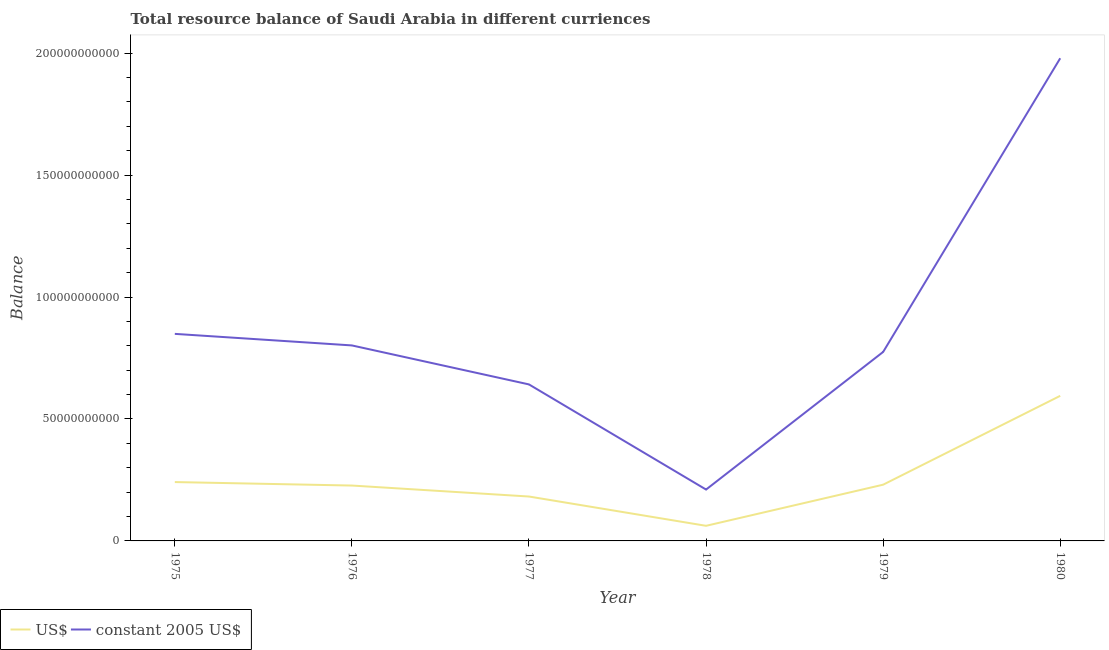Does the line corresponding to resource balance in us$ intersect with the line corresponding to resource balance in constant us$?
Make the answer very short. No. Is the number of lines equal to the number of legend labels?
Offer a terse response. Yes. What is the resource balance in us$ in 1977?
Provide a succinct answer. 1.82e+1. Across all years, what is the maximum resource balance in constant us$?
Offer a very short reply. 1.98e+11. Across all years, what is the minimum resource balance in constant us$?
Give a very brief answer. 2.11e+1. In which year was the resource balance in us$ minimum?
Your response must be concise. 1978. What is the total resource balance in us$ in the graph?
Your response must be concise. 1.54e+11. What is the difference between the resource balance in us$ in 1975 and that in 1979?
Provide a short and direct response. 1.08e+09. What is the difference between the resource balance in us$ in 1975 and the resource balance in constant us$ in 1976?
Your answer should be compact. -5.60e+1. What is the average resource balance in constant us$ per year?
Your answer should be compact. 8.76e+1. In the year 1979, what is the difference between the resource balance in constant us$ and resource balance in us$?
Your response must be concise. 5.44e+1. What is the ratio of the resource balance in constant us$ in 1978 to that in 1979?
Your answer should be very brief. 0.27. What is the difference between the highest and the second highest resource balance in us$?
Offer a terse response. 3.54e+1. What is the difference between the highest and the lowest resource balance in constant us$?
Your answer should be very brief. 1.77e+11. In how many years, is the resource balance in us$ greater than the average resource balance in us$ taken over all years?
Ensure brevity in your answer.  1. Is the sum of the resource balance in us$ in 1979 and 1980 greater than the maximum resource balance in constant us$ across all years?
Provide a short and direct response. No. Is the resource balance in constant us$ strictly greater than the resource balance in us$ over the years?
Offer a terse response. Yes. How many lines are there?
Your answer should be compact. 2. Are the values on the major ticks of Y-axis written in scientific E-notation?
Provide a succinct answer. No. How many legend labels are there?
Your answer should be very brief. 2. How are the legend labels stacked?
Your answer should be very brief. Horizontal. What is the title of the graph?
Provide a short and direct response. Total resource balance of Saudi Arabia in different curriences. What is the label or title of the X-axis?
Give a very brief answer. Year. What is the label or title of the Y-axis?
Offer a very short reply. Balance. What is the Balance of US$ in 1975?
Provide a short and direct response. 2.41e+1. What is the Balance of constant 2005 US$ in 1975?
Give a very brief answer. 8.49e+1. What is the Balance of US$ in 1976?
Your answer should be very brief. 2.27e+1. What is the Balance in constant 2005 US$ in 1976?
Give a very brief answer. 8.02e+1. What is the Balance in US$ in 1977?
Offer a terse response. 1.82e+1. What is the Balance in constant 2005 US$ in 1977?
Your answer should be compact. 6.42e+1. What is the Balance in US$ in 1978?
Ensure brevity in your answer.  6.20e+09. What is the Balance of constant 2005 US$ in 1978?
Make the answer very short. 2.11e+1. What is the Balance in US$ in 1979?
Offer a terse response. 2.31e+1. What is the Balance of constant 2005 US$ in 1979?
Give a very brief answer. 7.75e+1. What is the Balance in US$ in 1980?
Keep it short and to the point. 5.95e+1. What is the Balance of constant 2005 US$ in 1980?
Your answer should be compact. 1.98e+11. Across all years, what is the maximum Balance in US$?
Your answer should be very brief. 5.95e+1. Across all years, what is the maximum Balance of constant 2005 US$?
Offer a terse response. 1.98e+11. Across all years, what is the minimum Balance of US$?
Offer a terse response. 6.20e+09. Across all years, what is the minimum Balance in constant 2005 US$?
Your answer should be very brief. 2.11e+1. What is the total Balance of US$ in the graph?
Your answer should be very brief. 1.54e+11. What is the total Balance in constant 2005 US$ in the graph?
Provide a short and direct response. 5.26e+11. What is the difference between the Balance of US$ in 1975 and that in 1976?
Provide a short and direct response. 1.43e+09. What is the difference between the Balance of constant 2005 US$ in 1975 and that in 1976?
Keep it short and to the point. 4.74e+09. What is the difference between the Balance in US$ in 1975 and that in 1977?
Offer a very short reply. 5.93e+09. What is the difference between the Balance of constant 2005 US$ in 1975 and that in 1977?
Offer a terse response. 2.07e+1. What is the difference between the Balance of US$ in 1975 and that in 1978?
Ensure brevity in your answer.  1.79e+1. What is the difference between the Balance in constant 2005 US$ in 1975 and that in 1978?
Your response must be concise. 6.38e+1. What is the difference between the Balance in US$ in 1975 and that in 1979?
Offer a terse response. 1.08e+09. What is the difference between the Balance of constant 2005 US$ in 1975 and that in 1979?
Offer a terse response. 7.41e+09. What is the difference between the Balance in US$ in 1975 and that in 1980?
Make the answer very short. -3.54e+1. What is the difference between the Balance of constant 2005 US$ in 1975 and that in 1980?
Your response must be concise. -1.13e+11. What is the difference between the Balance in US$ in 1976 and that in 1977?
Keep it short and to the point. 4.50e+09. What is the difference between the Balance in constant 2005 US$ in 1976 and that in 1977?
Your response must be concise. 1.60e+1. What is the difference between the Balance in US$ in 1976 and that in 1978?
Your answer should be compact. 1.65e+1. What is the difference between the Balance in constant 2005 US$ in 1976 and that in 1978?
Keep it short and to the point. 5.91e+1. What is the difference between the Balance of US$ in 1976 and that in 1979?
Ensure brevity in your answer.  -3.49e+08. What is the difference between the Balance of constant 2005 US$ in 1976 and that in 1979?
Provide a succinct answer. 2.67e+09. What is the difference between the Balance of US$ in 1976 and that in 1980?
Your response must be concise. -3.68e+1. What is the difference between the Balance in constant 2005 US$ in 1976 and that in 1980?
Make the answer very short. -1.18e+11. What is the difference between the Balance of US$ in 1977 and that in 1978?
Make the answer very short. 1.20e+1. What is the difference between the Balance of constant 2005 US$ in 1977 and that in 1978?
Your response must be concise. 4.31e+1. What is the difference between the Balance of US$ in 1977 and that in 1979?
Keep it short and to the point. -4.85e+09. What is the difference between the Balance in constant 2005 US$ in 1977 and that in 1979?
Your answer should be compact. -1.33e+1. What is the difference between the Balance in US$ in 1977 and that in 1980?
Ensure brevity in your answer.  -4.13e+1. What is the difference between the Balance in constant 2005 US$ in 1977 and that in 1980?
Your answer should be compact. -1.34e+11. What is the difference between the Balance of US$ in 1978 and that in 1979?
Offer a terse response. -1.69e+1. What is the difference between the Balance of constant 2005 US$ in 1978 and that in 1979?
Your answer should be very brief. -5.64e+1. What is the difference between the Balance of US$ in 1978 and that in 1980?
Ensure brevity in your answer.  -5.33e+1. What is the difference between the Balance of constant 2005 US$ in 1978 and that in 1980?
Give a very brief answer. -1.77e+11. What is the difference between the Balance in US$ in 1979 and that in 1980?
Offer a terse response. -3.64e+1. What is the difference between the Balance of constant 2005 US$ in 1979 and that in 1980?
Ensure brevity in your answer.  -1.20e+11. What is the difference between the Balance in US$ in 1975 and the Balance in constant 2005 US$ in 1976?
Provide a short and direct response. -5.60e+1. What is the difference between the Balance in US$ in 1975 and the Balance in constant 2005 US$ in 1977?
Your answer should be compact. -4.00e+1. What is the difference between the Balance of US$ in 1975 and the Balance of constant 2005 US$ in 1978?
Offer a terse response. 3.07e+09. What is the difference between the Balance in US$ in 1975 and the Balance in constant 2005 US$ in 1979?
Ensure brevity in your answer.  -5.34e+1. What is the difference between the Balance in US$ in 1975 and the Balance in constant 2005 US$ in 1980?
Ensure brevity in your answer.  -1.74e+11. What is the difference between the Balance of US$ in 1976 and the Balance of constant 2005 US$ in 1977?
Provide a succinct answer. -4.15e+1. What is the difference between the Balance in US$ in 1976 and the Balance in constant 2005 US$ in 1978?
Your response must be concise. 1.64e+09. What is the difference between the Balance of US$ in 1976 and the Balance of constant 2005 US$ in 1979?
Offer a terse response. -5.48e+1. What is the difference between the Balance in US$ in 1976 and the Balance in constant 2005 US$ in 1980?
Ensure brevity in your answer.  -1.75e+11. What is the difference between the Balance of US$ in 1977 and the Balance of constant 2005 US$ in 1978?
Give a very brief answer. -2.86e+09. What is the difference between the Balance in US$ in 1977 and the Balance in constant 2005 US$ in 1979?
Give a very brief answer. -5.93e+1. What is the difference between the Balance in US$ in 1977 and the Balance in constant 2005 US$ in 1980?
Offer a terse response. -1.80e+11. What is the difference between the Balance of US$ in 1978 and the Balance of constant 2005 US$ in 1979?
Offer a very short reply. -7.13e+1. What is the difference between the Balance in US$ in 1978 and the Balance in constant 2005 US$ in 1980?
Offer a very short reply. -1.92e+11. What is the difference between the Balance of US$ in 1979 and the Balance of constant 2005 US$ in 1980?
Keep it short and to the point. -1.75e+11. What is the average Balance of US$ per year?
Offer a terse response. 2.56e+1. What is the average Balance of constant 2005 US$ per year?
Provide a succinct answer. 8.76e+1. In the year 1975, what is the difference between the Balance in US$ and Balance in constant 2005 US$?
Your response must be concise. -6.08e+1. In the year 1976, what is the difference between the Balance of US$ and Balance of constant 2005 US$?
Provide a succinct answer. -5.75e+1. In the year 1977, what is the difference between the Balance of US$ and Balance of constant 2005 US$?
Offer a terse response. -4.60e+1. In the year 1978, what is the difference between the Balance in US$ and Balance in constant 2005 US$?
Your response must be concise. -1.49e+1. In the year 1979, what is the difference between the Balance in US$ and Balance in constant 2005 US$?
Provide a short and direct response. -5.44e+1. In the year 1980, what is the difference between the Balance of US$ and Balance of constant 2005 US$?
Your response must be concise. -1.38e+11. What is the ratio of the Balance in US$ in 1975 to that in 1976?
Your response must be concise. 1.06. What is the ratio of the Balance of constant 2005 US$ in 1975 to that in 1976?
Offer a very short reply. 1.06. What is the ratio of the Balance of US$ in 1975 to that in 1977?
Your answer should be very brief. 1.33. What is the ratio of the Balance of constant 2005 US$ in 1975 to that in 1977?
Keep it short and to the point. 1.32. What is the ratio of the Balance in US$ in 1975 to that in 1978?
Ensure brevity in your answer.  3.9. What is the ratio of the Balance in constant 2005 US$ in 1975 to that in 1978?
Offer a terse response. 4.03. What is the ratio of the Balance of US$ in 1975 to that in 1979?
Provide a succinct answer. 1.05. What is the ratio of the Balance in constant 2005 US$ in 1975 to that in 1979?
Make the answer very short. 1.1. What is the ratio of the Balance of US$ in 1975 to that in 1980?
Provide a succinct answer. 0.41. What is the ratio of the Balance of constant 2005 US$ in 1975 to that in 1980?
Keep it short and to the point. 0.43. What is the ratio of the Balance of US$ in 1976 to that in 1977?
Your answer should be very brief. 1.25. What is the ratio of the Balance in constant 2005 US$ in 1976 to that in 1977?
Provide a short and direct response. 1.25. What is the ratio of the Balance in US$ in 1976 to that in 1978?
Offer a terse response. 3.67. What is the ratio of the Balance of constant 2005 US$ in 1976 to that in 1978?
Keep it short and to the point. 3.81. What is the ratio of the Balance in US$ in 1976 to that in 1979?
Offer a terse response. 0.98. What is the ratio of the Balance in constant 2005 US$ in 1976 to that in 1979?
Keep it short and to the point. 1.03. What is the ratio of the Balance of US$ in 1976 to that in 1980?
Give a very brief answer. 0.38. What is the ratio of the Balance of constant 2005 US$ in 1976 to that in 1980?
Provide a short and direct response. 0.41. What is the ratio of the Balance in US$ in 1977 to that in 1978?
Your answer should be very brief. 2.94. What is the ratio of the Balance of constant 2005 US$ in 1977 to that in 1978?
Offer a very short reply. 3.05. What is the ratio of the Balance of US$ in 1977 to that in 1979?
Offer a terse response. 0.79. What is the ratio of the Balance of constant 2005 US$ in 1977 to that in 1979?
Give a very brief answer. 0.83. What is the ratio of the Balance in US$ in 1977 to that in 1980?
Provide a succinct answer. 0.31. What is the ratio of the Balance in constant 2005 US$ in 1977 to that in 1980?
Give a very brief answer. 0.32. What is the ratio of the Balance of US$ in 1978 to that in 1979?
Provide a short and direct response. 0.27. What is the ratio of the Balance in constant 2005 US$ in 1978 to that in 1979?
Provide a succinct answer. 0.27. What is the ratio of the Balance in US$ in 1978 to that in 1980?
Offer a terse response. 0.1. What is the ratio of the Balance of constant 2005 US$ in 1978 to that in 1980?
Offer a terse response. 0.11. What is the ratio of the Balance of US$ in 1979 to that in 1980?
Offer a very short reply. 0.39. What is the ratio of the Balance of constant 2005 US$ in 1979 to that in 1980?
Your response must be concise. 0.39. What is the difference between the highest and the second highest Balance in US$?
Offer a very short reply. 3.54e+1. What is the difference between the highest and the second highest Balance in constant 2005 US$?
Provide a succinct answer. 1.13e+11. What is the difference between the highest and the lowest Balance in US$?
Make the answer very short. 5.33e+1. What is the difference between the highest and the lowest Balance of constant 2005 US$?
Provide a succinct answer. 1.77e+11. 